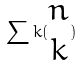Convert formula to latex. <formula><loc_0><loc_0><loc_500><loc_500>\sum k ( \begin{matrix} n \\ k \end{matrix} )</formula> 